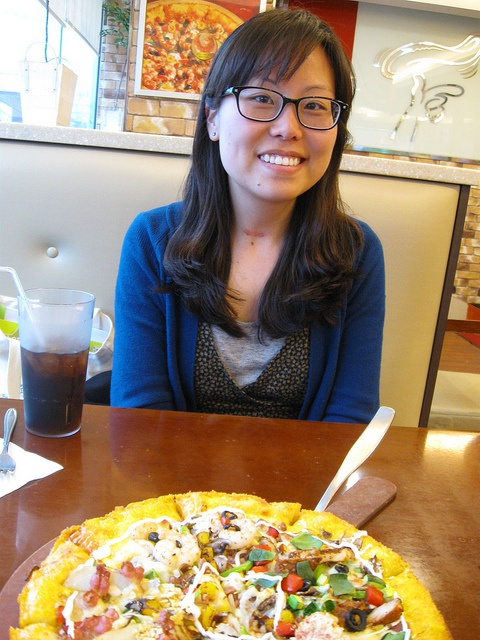Describe the objects in this image and their specific colors. I can see people in white, black, navy, gray, and maroon tones, pizza in white, ivory, khaki, and gold tones, dining table in white, brown, and maroon tones, cup in white, lavender, black, lightblue, and gray tones, and fork in white, lightblue, and darkgray tones in this image. 